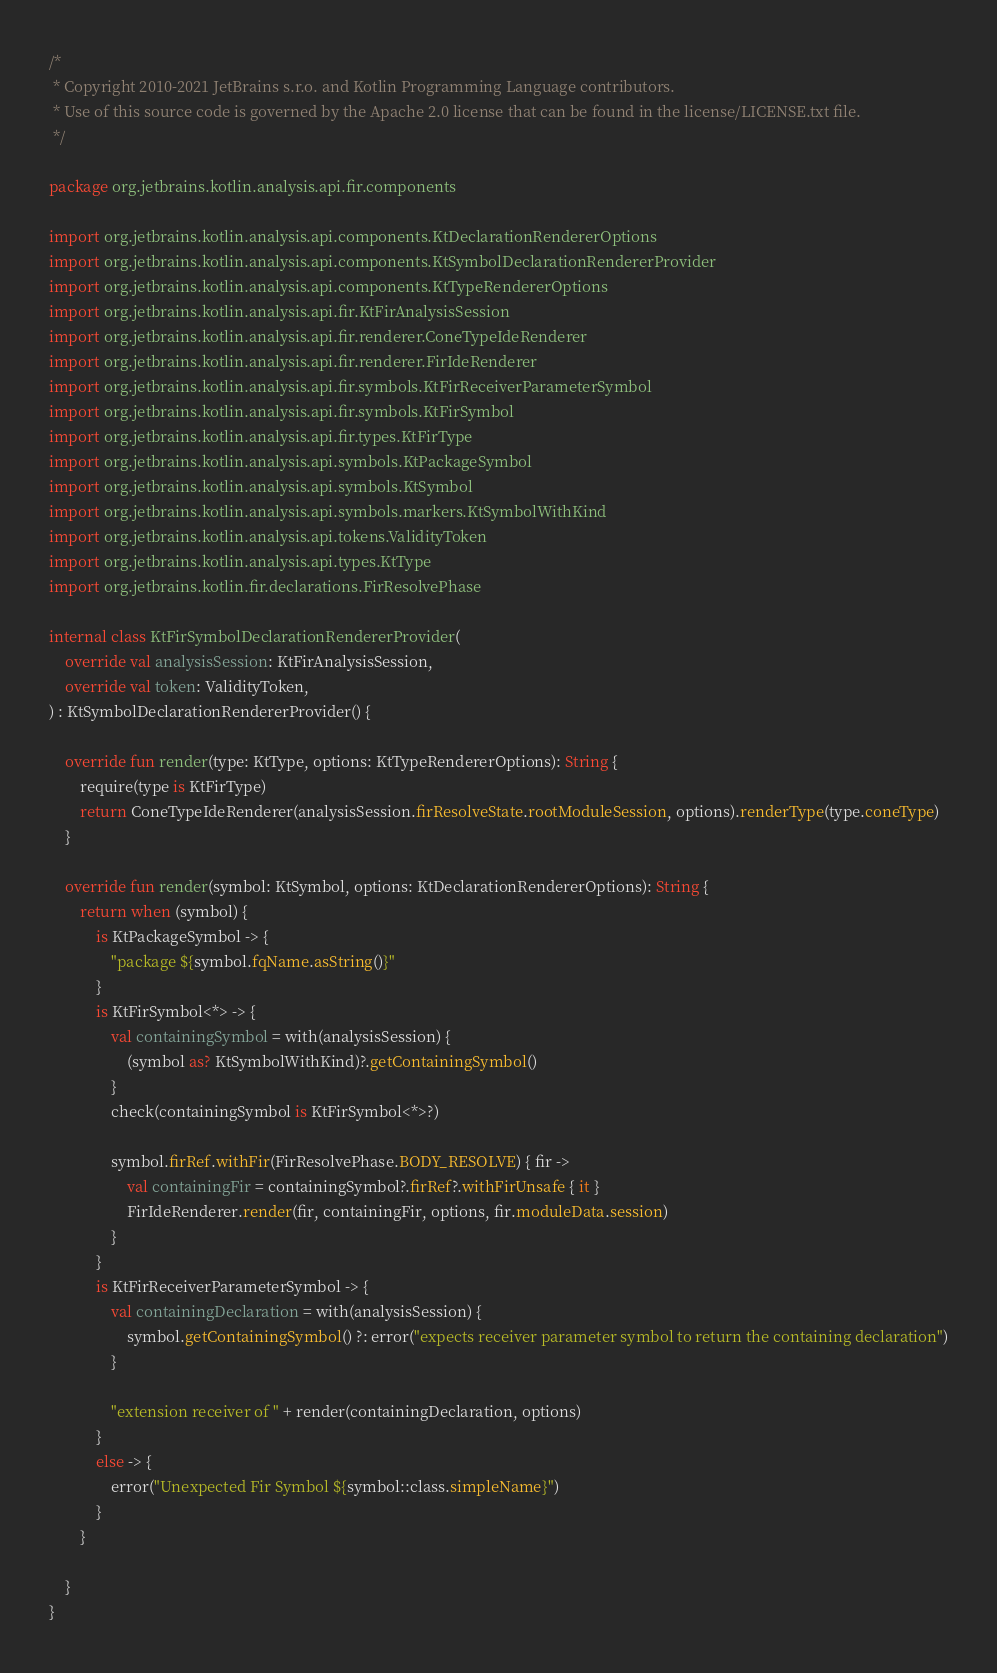<code> <loc_0><loc_0><loc_500><loc_500><_Kotlin_>/*
 * Copyright 2010-2021 JetBrains s.r.o. and Kotlin Programming Language contributors.
 * Use of this source code is governed by the Apache 2.0 license that can be found in the license/LICENSE.txt file.
 */

package org.jetbrains.kotlin.analysis.api.fir.components

import org.jetbrains.kotlin.analysis.api.components.KtDeclarationRendererOptions
import org.jetbrains.kotlin.analysis.api.components.KtSymbolDeclarationRendererProvider
import org.jetbrains.kotlin.analysis.api.components.KtTypeRendererOptions
import org.jetbrains.kotlin.analysis.api.fir.KtFirAnalysisSession
import org.jetbrains.kotlin.analysis.api.fir.renderer.ConeTypeIdeRenderer
import org.jetbrains.kotlin.analysis.api.fir.renderer.FirIdeRenderer
import org.jetbrains.kotlin.analysis.api.fir.symbols.KtFirReceiverParameterSymbol
import org.jetbrains.kotlin.analysis.api.fir.symbols.KtFirSymbol
import org.jetbrains.kotlin.analysis.api.fir.types.KtFirType
import org.jetbrains.kotlin.analysis.api.symbols.KtPackageSymbol
import org.jetbrains.kotlin.analysis.api.symbols.KtSymbol
import org.jetbrains.kotlin.analysis.api.symbols.markers.KtSymbolWithKind
import org.jetbrains.kotlin.analysis.api.tokens.ValidityToken
import org.jetbrains.kotlin.analysis.api.types.KtType
import org.jetbrains.kotlin.fir.declarations.FirResolvePhase

internal class KtFirSymbolDeclarationRendererProvider(
    override val analysisSession: KtFirAnalysisSession,
    override val token: ValidityToken,
) : KtSymbolDeclarationRendererProvider() {

    override fun render(type: KtType, options: KtTypeRendererOptions): String {
        require(type is KtFirType)
        return ConeTypeIdeRenderer(analysisSession.firResolveState.rootModuleSession, options).renderType(type.coneType)
    }

    override fun render(symbol: KtSymbol, options: KtDeclarationRendererOptions): String {
        return when (symbol) {
            is KtPackageSymbol -> {
                "package ${symbol.fqName.asString()}"
            }
            is KtFirSymbol<*> -> {
                val containingSymbol = with(analysisSession) {
                    (symbol as? KtSymbolWithKind)?.getContainingSymbol()
                }
                check(containingSymbol is KtFirSymbol<*>?)

                symbol.firRef.withFir(FirResolvePhase.BODY_RESOLVE) { fir ->
                    val containingFir = containingSymbol?.firRef?.withFirUnsafe { it }
                    FirIdeRenderer.render(fir, containingFir, options, fir.moduleData.session)
                }
            }
            is KtFirReceiverParameterSymbol -> {
                val containingDeclaration = with(analysisSession) {
                    symbol.getContainingSymbol() ?: error("expects receiver parameter symbol to return the containing declaration")
                }

                "extension receiver of " + render(containingDeclaration, options)
            }
            else -> {
                error("Unexpected Fir Symbol ${symbol::class.simpleName}")
            }
        }

    }
}
</code> 